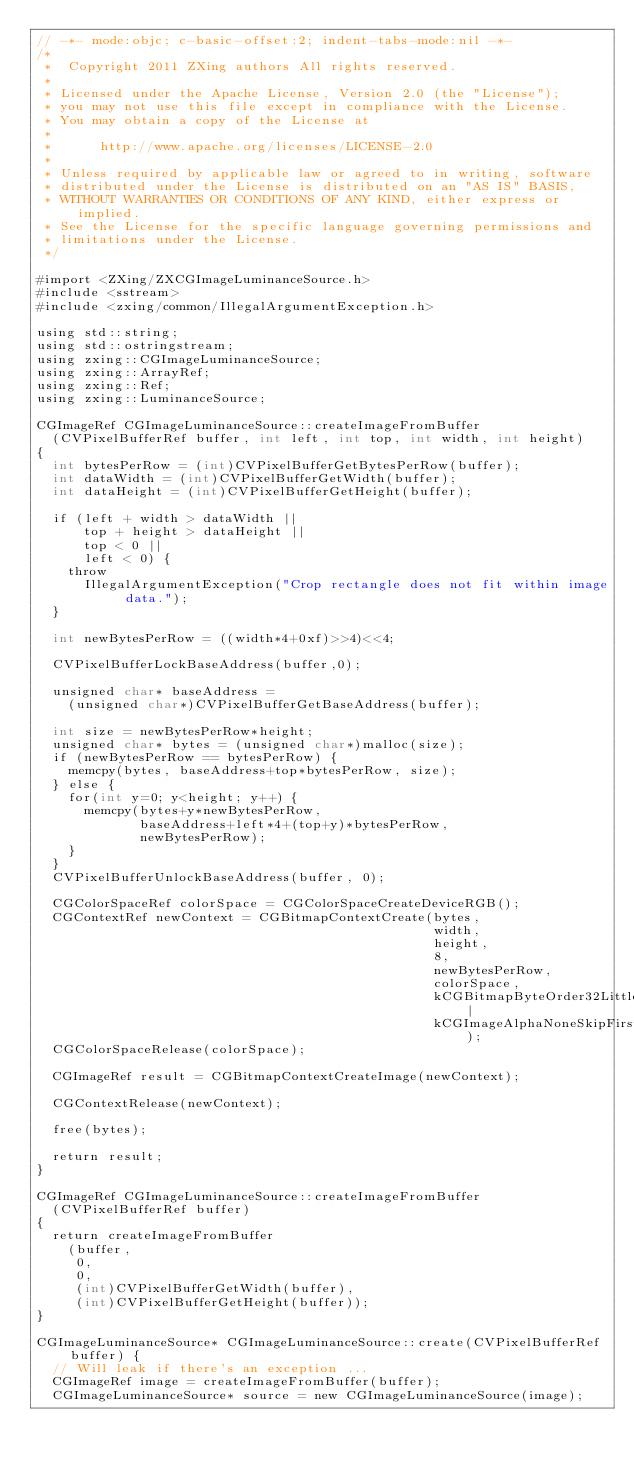Convert code to text. <code><loc_0><loc_0><loc_500><loc_500><_ObjectiveC_>// -*- mode:objc; c-basic-offset:2; indent-tabs-mode:nil -*-
/*
 *  Copyright 2011 ZXing authors All rights reserved.
 *
 * Licensed under the Apache License, Version 2.0 (the "License");
 * you may not use this file except in compliance with the License.
 * You may obtain a copy of the License at
 *
 *      http://www.apache.org/licenses/LICENSE-2.0
 *
 * Unless required by applicable law or agreed to in writing, software
 * distributed under the License is distributed on an "AS IS" BASIS,
 * WITHOUT WARRANTIES OR CONDITIONS OF ANY KIND, either express or implied.
 * See the License for the specific language governing permissions and
 * limitations under the License.
 */

#import <ZXing/ZXCGImageLuminanceSource.h>
#include <sstream>
#include <zxing/common/IllegalArgumentException.h>

using std::string;
using std::ostringstream;
using zxing::CGImageLuminanceSource;
using zxing::ArrayRef;
using zxing::Ref;
using zxing::LuminanceSource;

CGImageRef CGImageLuminanceSource::createImageFromBuffer
  (CVPixelBufferRef buffer, int left, int top, int width, int height)
{
  int bytesPerRow = (int)CVPixelBufferGetBytesPerRow(buffer); 
  int dataWidth = (int)CVPixelBufferGetWidth(buffer); 
  int dataHeight = (int)CVPixelBufferGetHeight(buffer); 
    
  if (left + width > dataWidth ||
      top + height > dataHeight || 
      top < 0 ||
      left < 0) {
    throw
      IllegalArgumentException("Crop rectangle does not fit within image data.");
  }

  int newBytesPerRow = ((width*4+0xf)>>4)<<4;

  CVPixelBufferLockBaseAddress(buffer,0); 

  unsigned char* baseAddress =
    (unsigned char*)CVPixelBufferGetBaseAddress(buffer); 

  int size = newBytesPerRow*height;
  unsigned char* bytes = (unsigned char*)malloc(size);
  if (newBytesPerRow == bytesPerRow) {
    memcpy(bytes, baseAddress+top*bytesPerRow, size);
  } else {
    for(int y=0; y<height; y++) {
      memcpy(bytes+y*newBytesPerRow,
             baseAddress+left*4+(top+y)*bytesPerRow,
             newBytesPerRow);
    }
  }
  CVPixelBufferUnlockBaseAddress(buffer, 0);

  CGColorSpaceRef colorSpace = CGColorSpaceCreateDeviceRGB(); 
  CGContextRef newContext = CGBitmapContextCreate(bytes,
                                                  width,
                                                  height,
                                                  8,
                                                  newBytesPerRow,
                                                  colorSpace,
                                                  kCGBitmapByteOrder32Little|
                                                  kCGImageAlphaNoneSkipFirst);
  CGColorSpaceRelease(colorSpace);

  CGImageRef result = CGBitmapContextCreateImage(newContext); 

  CGContextRelease(newContext); 

  free(bytes);

  return result;
}

CGImageRef CGImageLuminanceSource::createImageFromBuffer
  (CVPixelBufferRef buffer)
{
  return createImageFromBuffer
    (buffer,
     0,
     0,
     (int)CVPixelBufferGetWidth(buffer),
     (int)CVPixelBufferGetHeight(buffer));
}

CGImageLuminanceSource* CGImageLuminanceSource::create(CVPixelBufferRef buffer) {
  // Will leak if there's an exception ...
  CGImageRef image = createImageFromBuffer(buffer);
  CGImageLuminanceSource* source = new CGImageLuminanceSource(image);</code> 